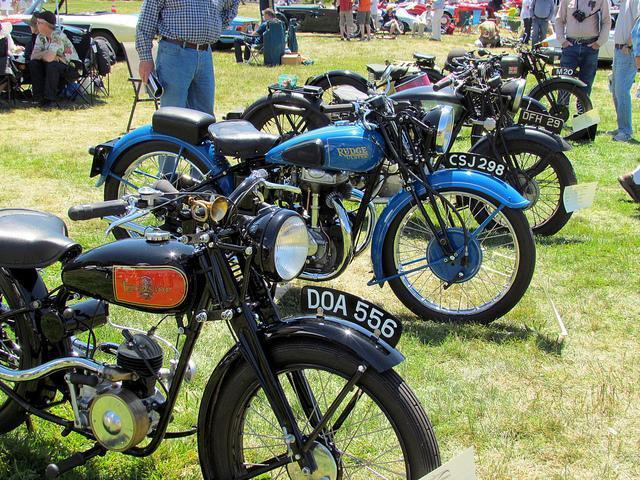How many motorcycles can be seen?
Give a very brief answer. 4. How many people can you see?
Give a very brief answer. 5. 